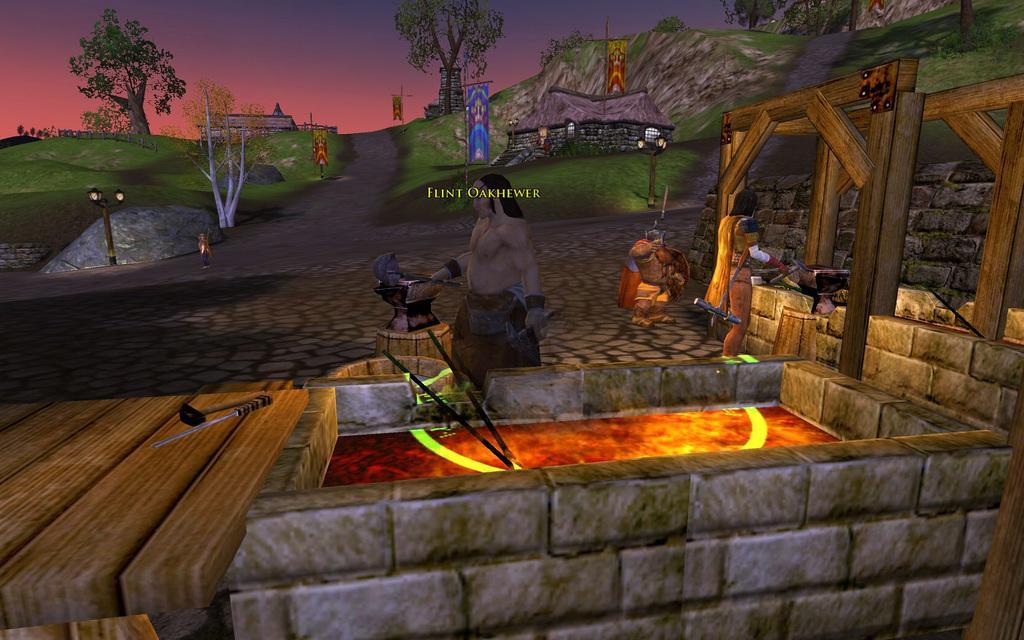Please provide a concise description of this image. This is an animated image. At the bottom there is a wall. On the right side there are few wooden pillars. Here I can see few people. On the left side there are few objects on a table. In the background there are some trees and also I can see few banners. At the top of the image I can see the sky. 